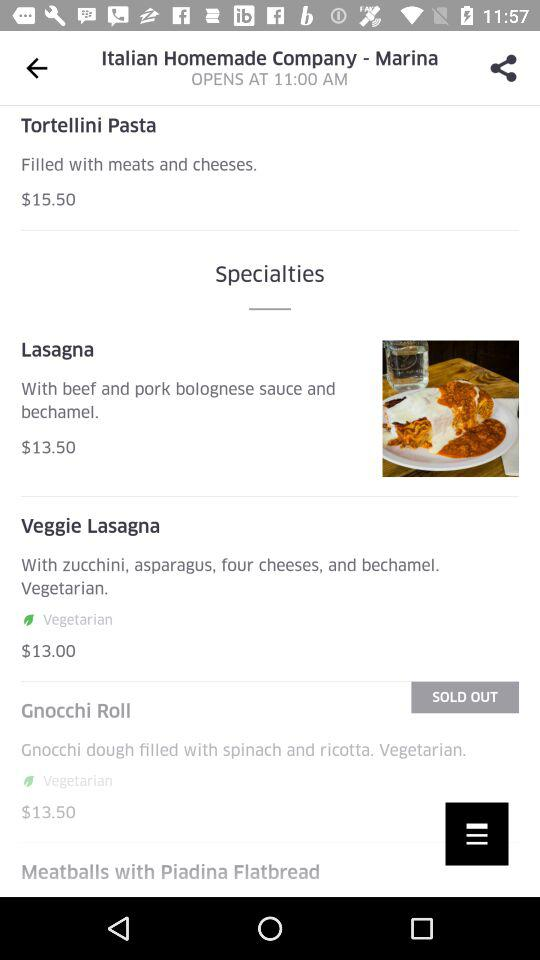What is the price of "Lasagna"? The price of "Lasagna" is $13.50. 